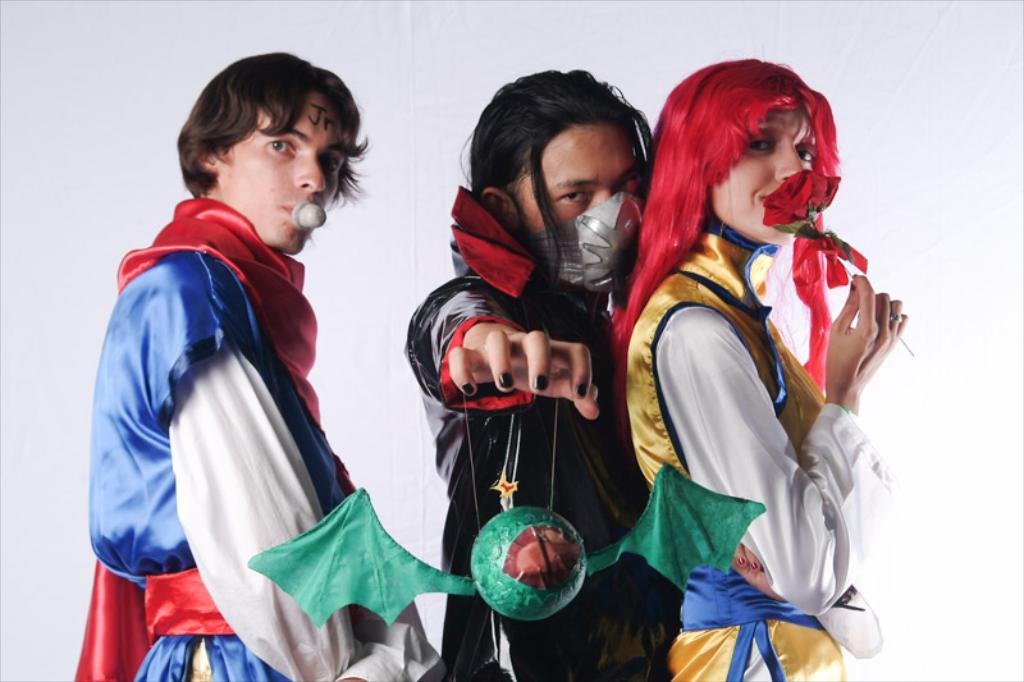What are the persons in the image wearing? The persons in the image are wearing costumes. What is the surface on which the persons are standing? The persons are standing on the floor. What can be seen in the background of the image? There is a wall in the background of the image. What type of cannon is being used to bake the pie in the image? There is no cannon or pie present in the image; it features persons wearing costumes. How does the light affect the appearance of the costumes in the image? The provided facts do not mention any specific lighting conditions, so we cannot determine how the light affects the appearance of the costumes in the image. 